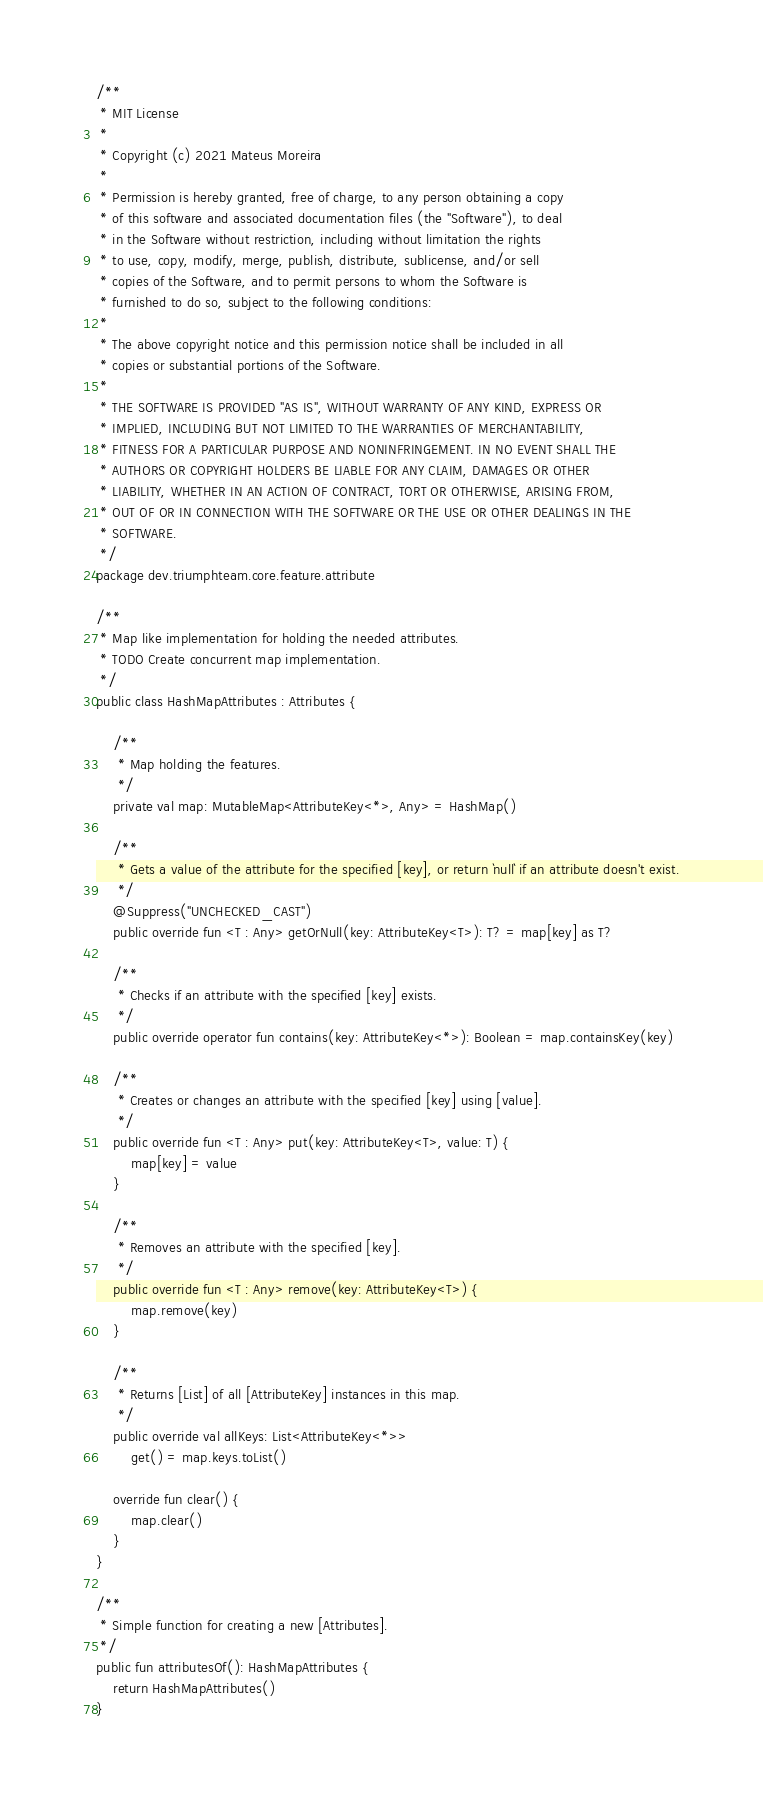<code> <loc_0><loc_0><loc_500><loc_500><_Kotlin_>/**
 * MIT License
 *
 * Copyright (c) 2021 Mateus Moreira
 *
 * Permission is hereby granted, free of charge, to any person obtaining a copy
 * of this software and associated documentation files (the "Software"), to deal
 * in the Software without restriction, including without limitation the rights
 * to use, copy, modify, merge, publish, distribute, sublicense, and/or sell
 * copies of the Software, and to permit persons to whom the Software is
 * furnished to do so, subject to the following conditions:
 *
 * The above copyright notice and this permission notice shall be included in all
 * copies or substantial portions of the Software.
 *
 * THE SOFTWARE IS PROVIDED "AS IS", WITHOUT WARRANTY OF ANY KIND, EXPRESS OR
 * IMPLIED, INCLUDING BUT NOT LIMITED TO THE WARRANTIES OF MERCHANTABILITY,
 * FITNESS FOR A PARTICULAR PURPOSE AND NONINFRINGEMENT. IN NO EVENT SHALL THE
 * AUTHORS OR COPYRIGHT HOLDERS BE LIABLE FOR ANY CLAIM, DAMAGES OR OTHER
 * LIABILITY, WHETHER IN AN ACTION OF CONTRACT, TORT OR OTHERWISE, ARISING FROM,
 * OUT OF OR IN CONNECTION WITH THE SOFTWARE OR THE USE OR OTHER DEALINGS IN THE
 * SOFTWARE.
 */
package dev.triumphteam.core.feature.attribute

/**
 * Map like implementation for holding the needed attributes.
 * TODO Create concurrent map implementation.
 */
public class HashMapAttributes : Attributes {

    /**
     * Map holding the features.
     */
    private val map: MutableMap<AttributeKey<*>, Any> = HashMap()

    /**
     * Gets a value of the attribute for the specified [key], or return `null` if an attribute doesn't exist.
     */
    @Suppress("UNCHECKED_CAST")
    public override fun <T : Any> getOrNull(key: AttributeKey<T>): T? = map[key] as T?

    /**
     * Checks if an attribute with the specified [key] exists.
     */
    public override operator fun contains(key: AttributeKey<*>): Boolean = map.containsKey(key)

    /**
     * Creates or changes an attribute with the specified [key] using [value].
     */
    public override fun <T : Any> put(key: AttributeKey<T>, value: T) {
        map[key] = value
    }

    /**
     * Removes an attribute with the specified [key].
     */
    public override fun <T : Any> remove(key: AttributeKey<T>) {
        map.remove(key)
    }

    /**
     * Returns [List] of all [AttributeKey] instances in this map.
     */
    public override val allKeys: List<AttributeKey<*>>
        get() = map.keys.toList()

    override fun clear() {
        map.clear()
    }
}

/**
 * Simple function for creating a new [Attributes].
 */
public fun attributesOf(): HashMapAttributes {
    return HashMapAttributes()
}</code> 